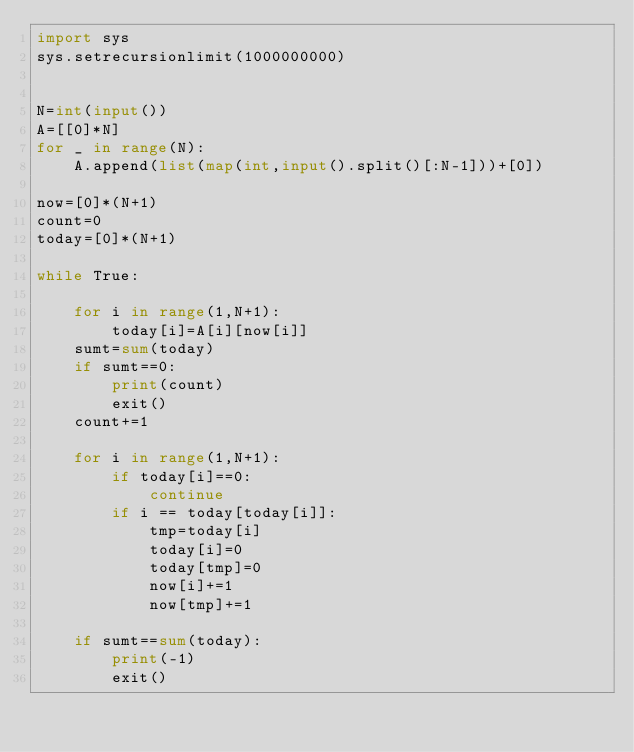<code> <loc_0><loc_0><loc_500><loc_500><_Python_>import sys
sys.setrecursionlimit(1000000000)


N=int(input())
A=[[0]*N]
for _ in range(N):
    A.append(list(map(int,input().split()[:N-1]))+[0])

now=[0]*(N+1)
count=0
today=[0]*(N+1)

while True:

    for i in range(1,N+1):
        today[i]=A[i][now[i]]
    sumt=sum(today)
    if sumt==0:
        print(count)
        exit()
    count+=1

    for i in range(1,N+1):
        if today[i]==0:
            continue
        if i == today[today[i]]:
            tmp=today[i]
            today[i]=0
            today[tmp]=0
            now[i]+=1
            now[tmp]+=1

    if sumt==sum(today):
        print(-1)
        exit()
</code> 